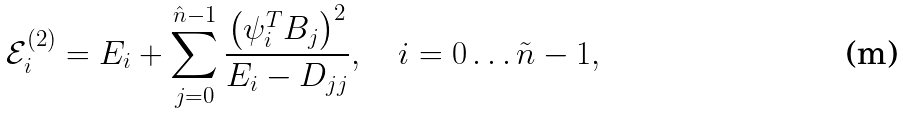Convert formula to latex. <formula><loc_0><loc_0><loc_500><loc_500>\mathcal { E } ^ { ( 2 ) } _ { i } = E _ { i } + \sum _ { j = 0 } ^ { \hat { n } - 1 } \frac { \left ( \psi _ { i } ^ { T } B _ { j } \right ) ^ { 2 } } { E _ { i } - D _ { j j } } , \quad i = 0 \dots \tilde { n } - 1 ,</formula> 